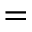<formula> <loc_0><loc_0><loc_500><loc_500>=</formula> 